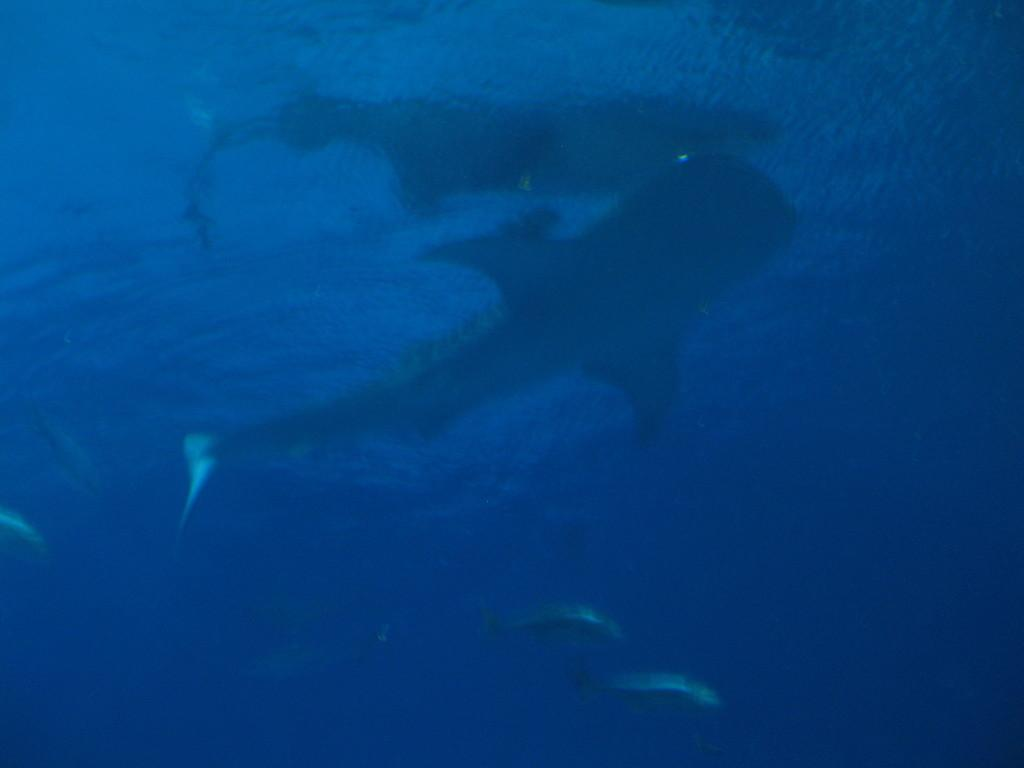What type of animals can be seen in the image? Fishes can be seen in the image. Where are the fishes located? The fishes are located in the water. What type of building can be seen in the image? There is no building present in the image; it features fishes in the water. What type of machine is being used by the fishes in the image? There is no machine present in the image, as it features fishes in the water. 